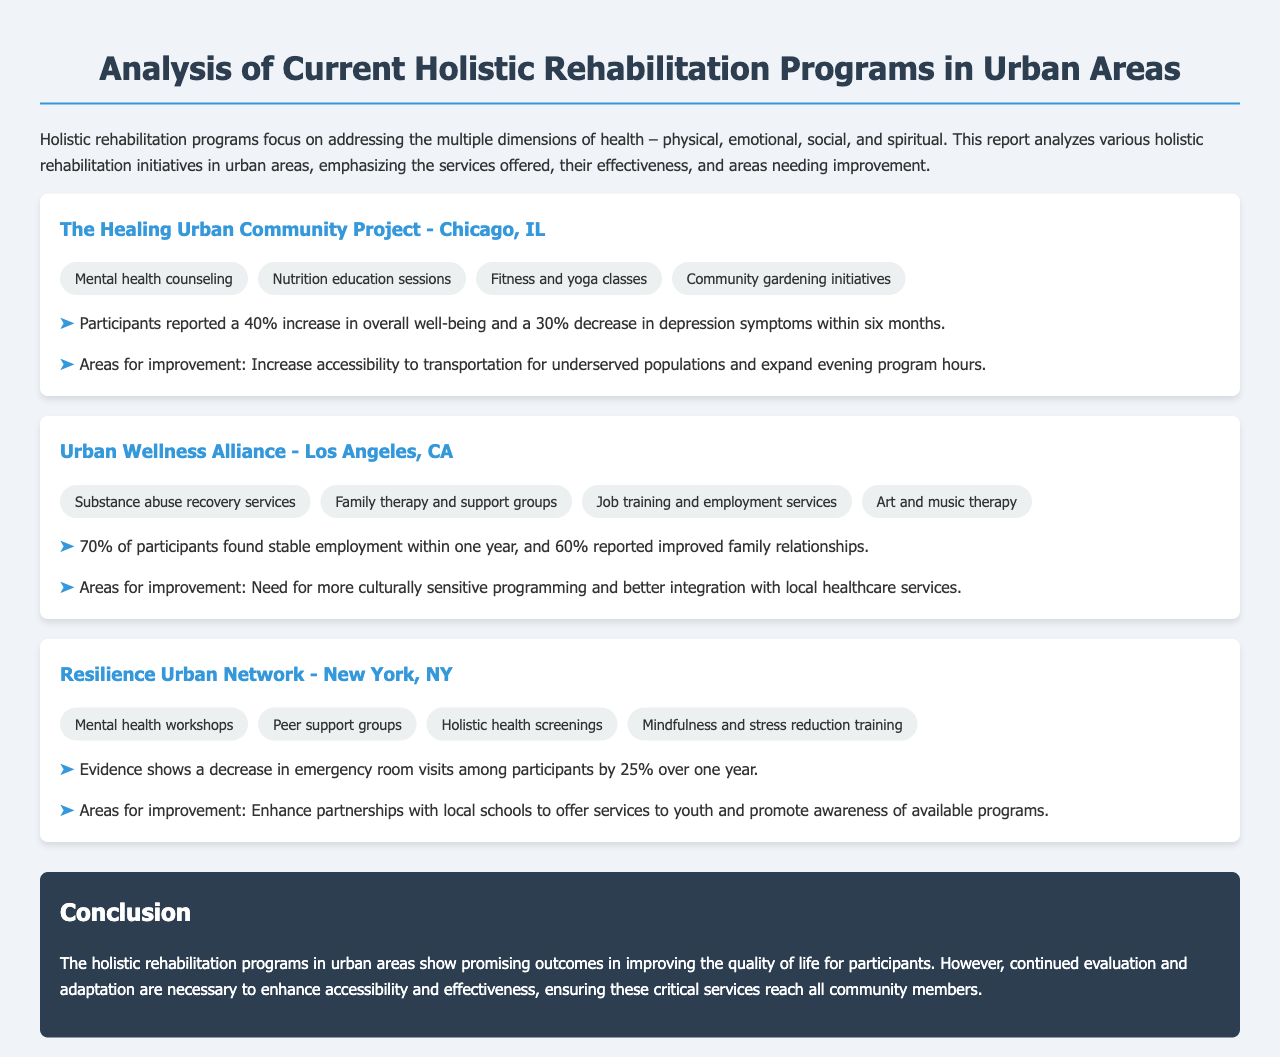What is the name of the program based in Chicago? The report mentions "The Healing Urban Community Project" as the program based in Chicago, IL.
Answer: The Healing Urban Community Project What services does the Urban Wellness Alliance offer? The Urban Wellness Alliance offers services including "Substance abuse recovery services," "Family therapy and support groups," "Job training and employment services," and "Art and music therapy."
Answer: Substance abuse recovery services, Family therapy and support groups, Job training and employment services, Art and music therapy What percentage of participants in the Resilience Urban Network saw a decrease in emergency room visits? The report states that participants experienced a 25% decrease in emergency room visits within one year.
Answer: 25% What area for improvement is suggested for The Healing Urban Community Project? The report suggests increasing accessibility to transportation and expanding evening program hours as areas for improvement.
Answer: Increase accessibility to transportation for underserved populations and expand evening program hours What was the employment rate for participants in the Urban Wellness Alliance after one year? The report indicates that 70% of participants found stable employment within one year.
Answer: 70% Which city is the Resilience Urban Network located in? According to the document, the Resilience Urban Network is based in New York, NY.
Answer: New York, NY What is the main focus of holistic rehabilitation programs mentioned in the report? The document highlights that holistic rehabilitation programs focus on addressing multiple dimensions of health, including physical, emotional, social, and spiritual aspects.
Answer: Multiple dimensions of health What conclusion is drawn regarding the effectiveness of holistic rehabilitation programs? The conclusion indicates that holistic rehabilitation programs show promising outcomes but require continued evaluation to enhance accessibility and effectiveness.
Answer: Promising outcomes in improving quality of life 